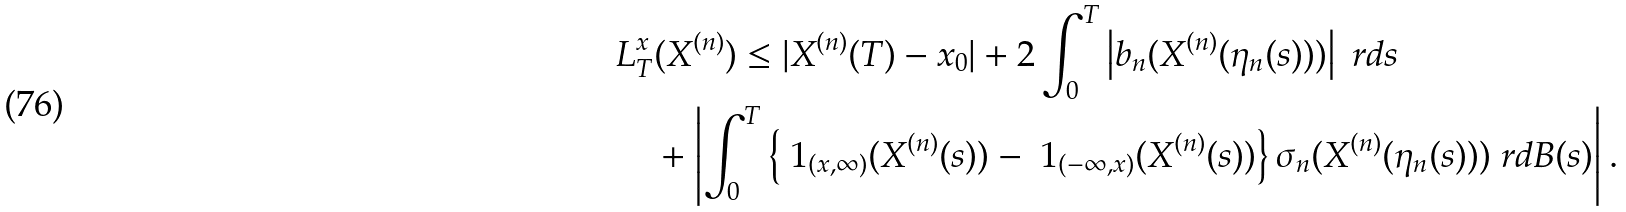<formula> <loc_0><loc_0><loc_500><loc_500>& L _ { T } ^ { x } ( X ^ { ( n ) } ) \leq | X ^ { ( n ) } ( T ) - x _ { 0 } | + 2 \int _ { 0 } ^ { T } \left | b _ { n } ( X ^ { ( n ) } ( \eta _ { n } ( s ) ) ) \right | \ r d s \\ & \quad + \left | \int _ { 0 } ^ { T } \left \{ \ 1 _ { ( x , \infty ) } ( X ^ { ( n ) } ( s ) ) - \ 1 _ { ( - \infty , x ) } ( X ^ { ( n ) } ( s ) ) \right \} \sigma _ { n } ( X ^ { ( n ) } ( \eta _ { n } ( s ) ) ) \ r d B ( s ) \right | .</formula> 